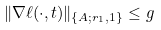<formula> <loc_0><loc_0><loc_500><loc_500>\| \nabla \ell ( \cdot , t ) \| _ { \{ A ; r _ { 1 } , 1 \} } \leq g</formula> 